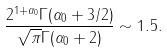<formula> <loc_0><loc_0><loc_500><loc_500>\frac { 2 ^ { 1 + \alpha _ { 0 } } \Gamma ( \alpha _ { 0 } + 3 / 2 ) } { \sqrt { \pi } \Gamma ( \alpha _ { 0 } + 2 ) } \sim 1 . 5 .</formula> 